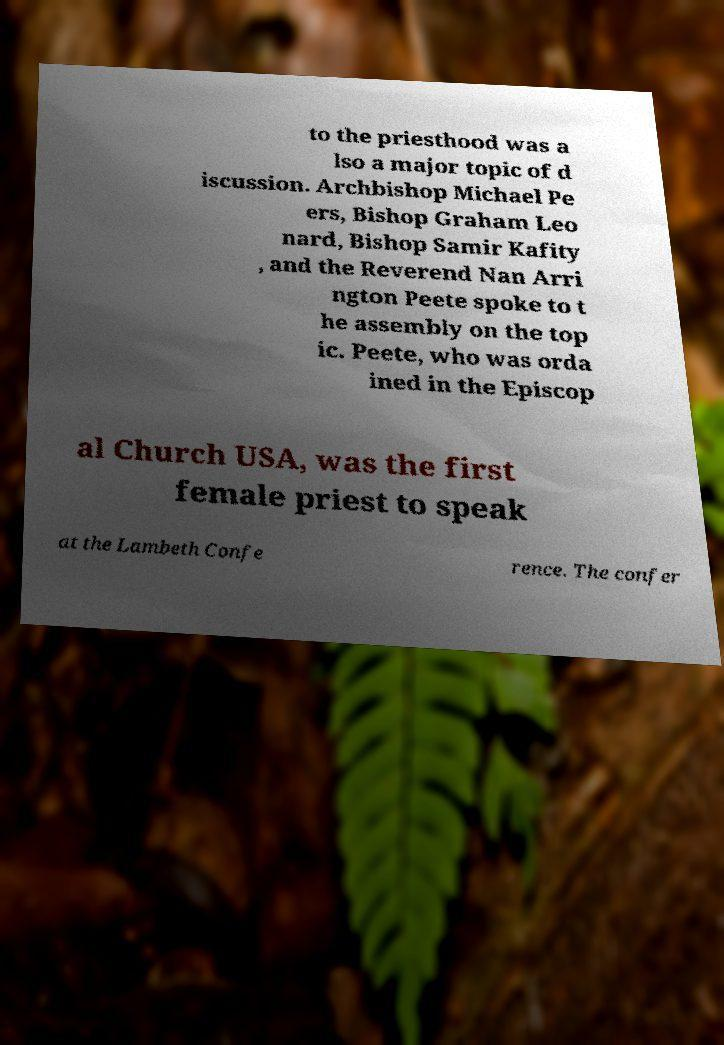What messages or text are displayed in this image? I need them in a readable, typed format. to the priesthood was a lso a major topic of d iscussion. Archbishop Michael Pe ers, Bishop Graham Leo nard, Bishop Samir Kafity , and the Reverend Nan Arri ngton Peete spoke to t he assembly on the top ic. Peete, who was orda ined in the Episcop al Church USA, was the first female priest to speak at the Lambeth Confe rence. The confer 